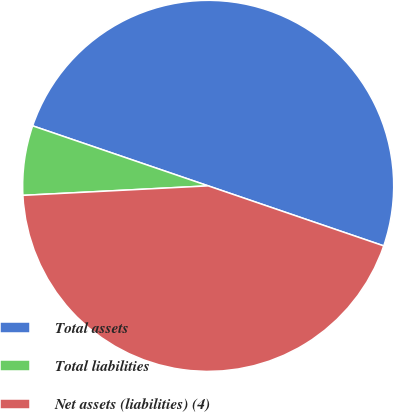<chart> <loc_0><loc_0><loc_500><loc_500><pie_chart><fcel>Total assets<fcel>Total liabilities<fcel>Net assets (liabilities) (4)<nl><fcel>50.0%<fcel>6.06%<fcel>43.94%<nl></chart> 